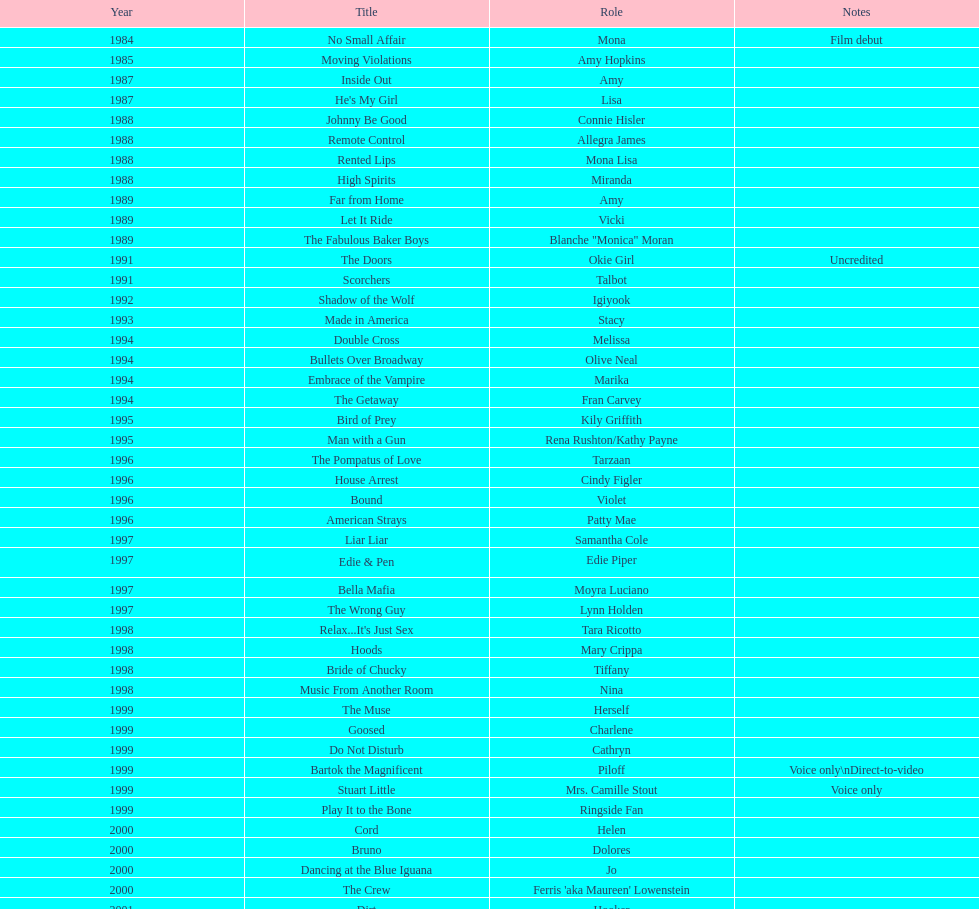Which movie was also a film debut? No Small Affair. 